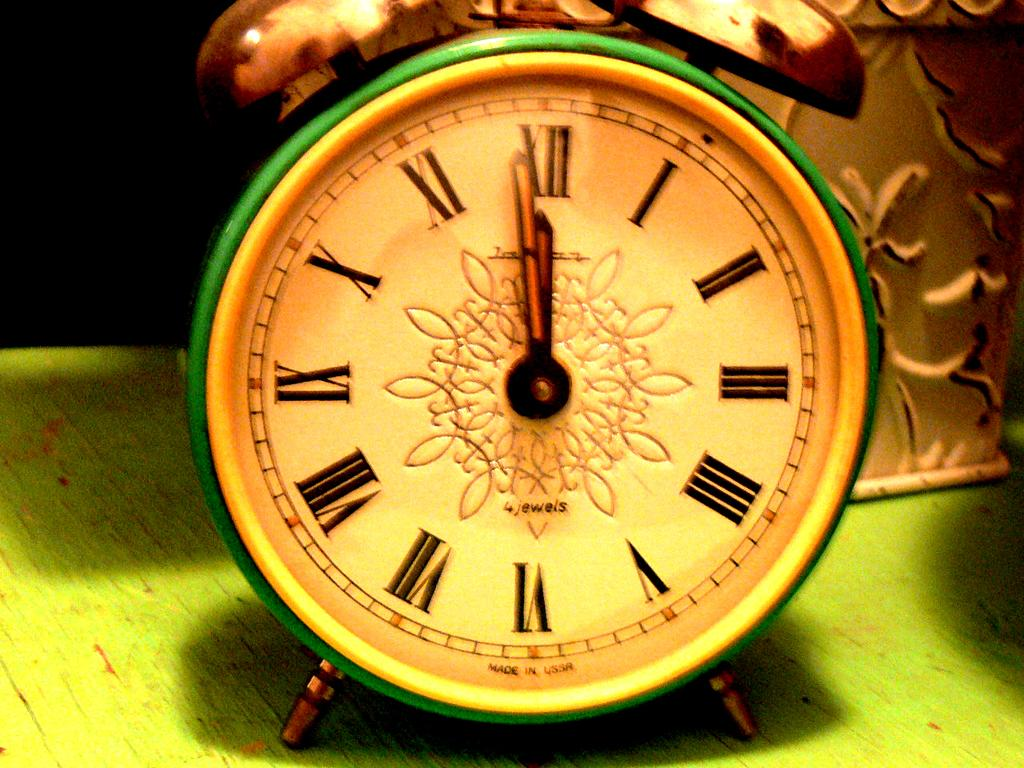What is the main object in the image? There is an alarm clock in the image. What is the surface beneath the alarm clock? The alarm clock is on a green surface. Can you describe the item behind the alarm clock? There is an item with a design behind the alarm clock. What type of pot is hanging from the curtain in the image? There is no pot or curtain present in the image. 